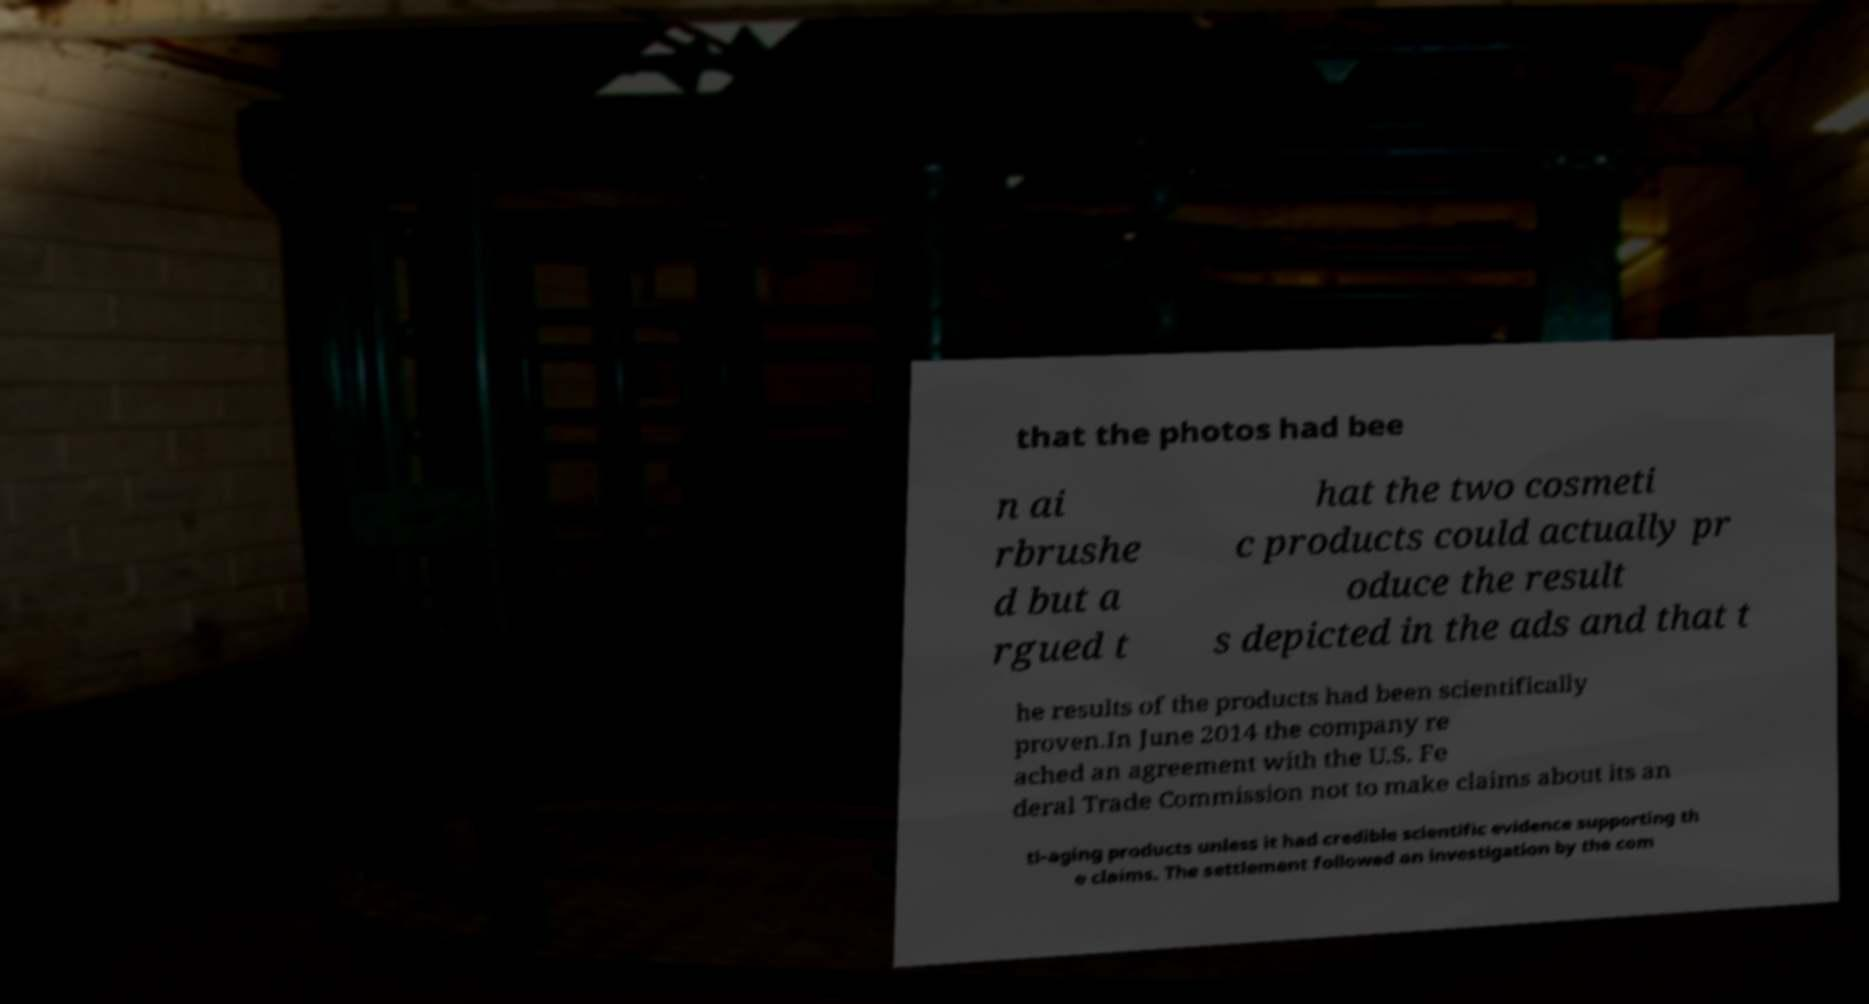Please read and relay the text visible in this image. What does it say? that the photos had bee n ai rbrushe d but a rgued t hat the two cosmeti c products could actually pr oduce the result s depicted in the ads and that t he results of the products had been scientifically proven.In June 2014 the company re ached an agreement with the U.S. Fe deral Trade Commission not to make claims about its an ti-aging products unless it had credible scientific evidence supporting th e claims. The settlement followed an investigation by the com 